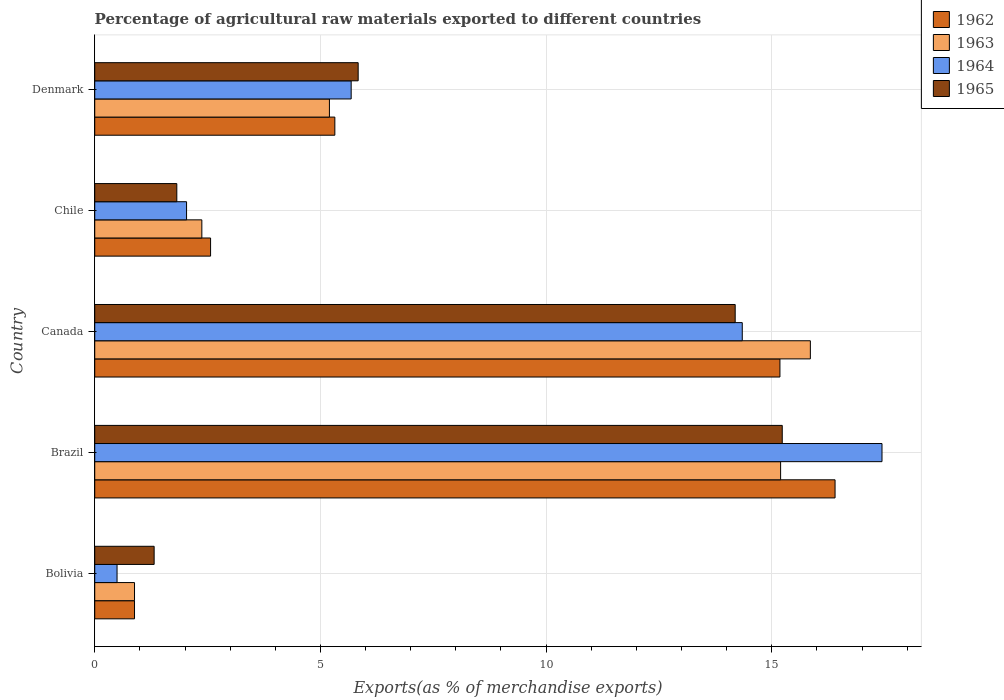How many different coloured bars are there?
Your answer should be very brief. 4. Are the number of bars per tick equal to the number of legend labels?
Ensure brevity in your answer.  Yes. How many bars are there on the 5th tick from the bottom?
Offer a very short reply. 4. In how many cases, is the number of bars for a given country not equal to the number of legend labels?
Your response must be concise. 0. What is the percentage of exports to different countries in 1963 in Brazil?
Make the answer very short. 15.2. Across all countries, what is the maximum percentage of exports to different countries in 1962?
Give a very brief answer. 16.4. Across all countries, what is the minimum percentage of exports to different countries in 1962?
Your answer should be compact. 0.88. What is the total percentage of exports to different countries in 1965 in the graph?
Provide a succinct answer. 38.39. What is the difference between the percentage of exports to different countries in 1964 in Bolivia and that in Chile?
Keep it short and to the point. -1.54. What is the difference between the percentage of exports to different countries in 1962 in Brazil and the percentage of exports to different countries in 1964 in Canada?
Your response must be concise. 2.06. What is the average percentage of exports to different countries in 1962 per country?
Offer a very short reply. 8.07. What is the difference between the percentage of exports to different countries in 1962 and percentage of exports to different countries in 1965 in Bolivia?
Ensure brevity in your answer.  -0.43. What is the ratio of the percentage of exports to different countries in 1964 in Bolivia to that in Chile?
Your answer should be very brief. 0.24. What is the difference between the highest and the second highest percentage of exports to different countries in 1963?
Keep it short and to the point. 0.66. What is the difference between the highest and the lowest percentage of exports to different countries in 1965?
Your answer should be very brief. 13.92. Is the sum of the percentage of exports to different countries in 1964 in Bolivia and Denmark greater than the maximum percentage of exports to different countries in 1962 across all countries?
Your answer should be compact. No. Is it the case that in every country, the sum of the percentage of exports to different countries in 1964 and percentage of exports to different countries in 1963 is greater than the sum of percentage of exports to different countries in 1962 and percentage of exports to different countries in 1965?
Give a very brief answer. No. What does the 1st bar from the top in Brazil represents?
Your answer should be compact. 1965. What does the 2nd bar from the bottom in Brazil represents?
Your answer should be compact. 1963. How many bars are there?
Make the answer very short. 20. Are all the bars in the graph horizontal?
Provide a short and direct response. Yes. What is the difference between two consecutive major ticks on the X-axis?
Provide a succinct answer. 5. Are the values on the major ticks of X-axis written in scientific E-notation?
Your answer should be very brief. No. Does the graph contain grids?
Offer a terse response. Yes. Where does the legend appear in the graph?
Provide a succinct answer. Top right. How many legend labels are there?
Ensure brevity in your answer.  4. How are the legend labels stacked?
Ensure brevity in your answer.  Vertical. What is the title of the graph?
Make the answer very short. Percentage of agricultural raw materials exported to different countries. What is the label or title of the X-axis?
Keep it short and to the point. Exports(as % of merchandise exports). What is the label or title of the Y-axis?
Your response must be concise. Country. What is the Exports(as % of merchandise exports) of 1962 in Bolivia?
Give a very brief answer. 0.88. What is the Exports(as % of merchandise exports) of 1963 in Bolivia?
Offer a very short reply. 0.88. What is the Exports(as % of merchandise exports) of 1964 in Bolivia?
Provide a succinct answer. 0.49. What is the Exports(as % of merchandise exports) of 1965 in Bolivia?
Your answer should be very brief. 1.32. What is the Exports(as % of merchandise exports) of 1962 in Brazil?
Your answer should be very brief. 16.4. What is the Exports(as % of merchandise exports) of 1963 in Brazil?
Keep it short and to the point. 15.2. What is the Exports(as % of merchandise exports) in 1964 in Brazil?
Your answer should be very brief. 17.44. What is the Exports(as % of merchandise exports) in 1965 in Brazil?
Your answer should be compact. 15.23. What is the Exports(as % of merchandise exports) of 1962 in Canada?
Provide a succinct answer. 15.18. What is the Exports(as % of merchandise exports) of 1963 in Canada?
Offer a very short reply. 15.85. What is the Exports(as % of merchandise exports) in 1964 in Canada?
Provide a short and direct response. 14.35. What is the Exports(as % of merchandise exports) of 1965 in Canada?
Give a very brief answer. 14.19. What is the Exports(as % of merchandise exports) in 1962 in Chile?
Provide a succinct answer. 2.57. What is the Exports(as % of merchandise exports) in 1963 in Chile?
Your answer should be compact. 2.37. What is the Exports(as % of merchandise exports) of 1964 in Chile?
Your answer should be very brief. 2.03. What is the Exports(as % of merchandise exports) in 1965 in Chile?
Provide a succinct answer. 1.82. What is the Exports(as % of merchandise exports) of 1962 in Denmark?
Keep it short and to the point. 5.32. What is the Exports(as % of merchandise exports) in 1963 in Denmark?
Ensure brevity in your answer.  5.2. What is the Exports(as % of merchandise exports) of 1964 in Denmark?
Your response must be concise. 5.68. What is the Exports(as % of merchandise exports) in 1965 in Denmark?
Make the answer very short. 5.84. Across all countries, what is the maximum Exports(as % of merchandise exports) of 1962?
Give a very brief answer. 16.4. Across all countries, what is the maximum Exports(as % of merchandise exports) of 1963?
Your response must be concise. 15.85. Across all countries, what is the maximum Exports(as % of merchandise exports) in 1964?
Offer a very short reply. 17.44. Across all countries, what is the maximum Exports(as % of merchandise exports) in 1965?
Your answer should be very brief. 15.23. Across all countries, what is the minimum Exports(as % of merchandise exports) of 1962?
Offer a very short reply. 0.88. Across all countries, what is the minimum Exports(as % of merchandise exports) in 1963?
Your response must be concise. 0.88. Across all countries, what is the minimum Exports(as % of merchandise exports) of 1964?
Give a very brief answer. 0.49. Across all countries, what is the minimum Exports(as % of merchandise exports) in 1965?
Make the answer very short. 1.32. What is the total Exports(as % of merchandise exports) in 1962 in the graph?
Your response must be concise. 40.35. What is the total Exports(as % of merchandise exports) in 1963 in the graph?
Offer a very short reply. 39.5. What is the total Exports(as % of merchandise exports) of 1964 in the graph?
Provide a succinct answer. 40. What is the total Exports(as % of merchandise exports) of 1965 in the graph?
Give a very brief answer. 38.39. What is the difference between the Exports(as % of merchandise exports) of 1962 in Bolivia and that in Brazil?
Ensure brevity in your answer.  -15.52. What is the difference between the Exports(as % of merchandise exports) in 1963 in Bolivia and that in Brazil?
Offer a very short reply. -14.31. What is the difference between the Exports(as % of merchandise exports) in 1964 in Bolivia and that in Brazil?
Your answer should be compact. -16.95. What is the difference between the Exports(as % of merchandise exports) of 1965 in Bolivia and that in Brazil?
Provide a short and direct response. -13.92. What is the difference between the Exports(as % of merchandise exports) of 1962 in Bolivia and that in Canada?
Your answer should be very brief. -14.3. What is the difference between the Exports(as % of merchandise exports) in 1963 in Bolivia and that in Canada?
Make the answer very short. -14.97. What is the difference between the Exports(as % of merchandise exports) in 1964 in Bolivia and that in Canada?
Provide a short and direct response. -13.85. What is the difference between the Exports(as % of merchandise exports) in 1965 in Bolivia and that in Canada?
Ensure brevity in your answer.  -12.87. What is the difference between the Exports(as % of merchandise exports) in 1962 in Bolivia and that in Chile?
Offer a terse response. -1.69. What is the difference between the Exports(as % of merchandise exports) in 1963 in Bolivia and that in Chile?
Your answer should be compact. -1.49. What is the difference between the Exports(as % of merchandise exports) of 1964 in Bolivia and that in Chile?
Keep it short and to the point. -1.54. What is the difference between the Exports(as % of merchandise exports) of 1965 in Bolivia and that in Chile?
Provide a succinct answer. -0.5. What is the difference between the Exports(as % of merchandise exports) of 1962 in Bolivia and that in Denmark?
Make the answer very short. -4.44. What is the difference between the Exports(as % of merchandise exports) in 1963 in Bolivia and that in Denmark?
Your answer should be compact. -4.32. What is the difference between the Exports(as % of merchandise exports) in 1964 in Bolivia and that in Denmark?
Make the answer very short. -5.19. What is the difference between the Exports(as % of merchandise exports) in 1965 in Bolivia and that in Denmark?
Provide a succinct answer. -4.52. What is the difference between the Exports(as % of merchandise exports) in 1962 in Brazil and that in Canada?
Make the answer very short. 1.22. What is the difference between the Exports(as % of merchandise exports) of 1963 in Brazil and that in Canada?
Offer a terse response. -0.66. What is the difference between the Exports(as % of merchandise exports) in 1964 in Brazil and that in Canada?
Your response must be concise. 3.1. What is the difference between the Exports(as % of merchandise exports) in 1965 in Brazil and that in Canada?
Offer a terse response. 1.04. What is the difference between the Exports(as % of merchandise exports) in 1962 in Brazil and that in Chile?
Your answer should be compact. 13.84. What is the difference between the Exports(as % of merchandise exports) of 1963 in Brazil and that in Chile?
Provide a short and direct response. 12.82. What is the difference between the Exports(as % of merchandise exports) in 1964 in Brazil and that in Chile?
Keep it short and to the point. 15.41. What is the difference between the Exports(as % of merchandise exports) in 1965 in Brazil and that in Chile?
Provide a succinct answer. 13.41. What is the difference between the Exports(as % of merchandise exports) in 1962 in Brazil and that in Denmark?
Provide a short and direct response. 11.08. What is the difference between the Exports(as % of merchandise exports) of 1963 in Brazil and that in Denmark?
Ensure brevity in your answer.  10. What is the difference between the Exports(as % of merchandise exports) of 1964 in Brazil and that in Denmark?
Your answer should be compact. 11.76. What is the difference between the Exports(as % of merchandise exports) of 1965 in Brazil and that in Denmark?
Provide a succinct answer. 9.4. What is the difference between the Exports(as % of merchandise exports) in 1962 in Canada and that in Chile?
Offer a terse response. 12.61. What is the difference between the Exports(as % of merchandise exports) of 1963 in Canada and that in Chile?
Offer a very short reply. 13.48. What is the difference between the Exports(as % of merchandise exports) in 1964 in Canada and that in Chile?
Ensure brevity in your answer.  12.31. What is the difference between the Exports(as % of merchandise exports) in 1965 in Canada and that in Chile?
Make the answer very short. 12.37. What is the difference between the Exports(as % of merchandise exports) in 1962 in Canada and that in Denmark?
Your answer should be compact. 9.86. What is the difference between the Exports(as % of merchandise exports) in 1963 in Canada and that in Denmark?
Keep it short and to the point. 10.65. What is the difference between the Exports(as % of merchandise exports) in 1964 in Canada and that in Denmark?
Your answer should be very brief. 8.66. What is the difference between the Exports(as % of merchandise exports) in 1965 in Canada and that in Denmark?
Give a very brief answer. 8.35. What is the difference between the Exports(as % of merchandise exports) of 1962 in Chile and that in Denmark?
Your answer should be very brief. -2.75. What is the difference between the Exports(as % of merchandise exports) in 1963 in Chile and that in Denmark?
Make the answer very short. -2.83. What is the difference between the Exports(as % of merchandise exports) in 1964 in Chile and that in Denmark?
Give a very brief answer. -3.65. What is the difference between the Exports(as % of merchandise exports) of 1965 in Chile and that in Denmark?
Keep it short and to the point. -4.02. What is the difference between the Exports(as % of merchandise exports) of 1962 in Bolivia and the Exports(as % of merchandise exports) of 1963 in Brazil?
Provide a short and direct response. -14.31. What is the difference between the Exports(as % of merchandise exports) of 1962 in Bolivia and the Exports(as % of merchandise exports) of 1964 in Brazil?
Offer a terse response. -16.56. What is the difference between the Exports(as % of merchandise exports) of 1962 in Bolivia and the Exports(as % of merchandise exports) of 1965 in Brazil?
Provide a short and direct response. -14.35. What is the difference between the Exports(as % of merchandise exports) of 1963 in Bolivia and the Exports(as % of merchandise exports) of 1964 in Brazil?
Provide a short and direct response. -16.56. What is the difference between the Exports(as % of merchandise exports) of 1963 in Bolivia and the Exports(as % of merchandise exports) of 1965 in Brazil?
Ensure brevity in your answer.  -14.35. What is the difference between the Exports(as % of merchandise exports) in 1964 in Bolivia and the Exports(as % of merchandise exports) in 1965 in Brazil?
Your answer should be very brief. -14.74. What is the difference between the Exports(as % of merchandise exports) in 1962 in Bolivia and the Exports(as % of merchandise exports) in 1963 in Canada?
Provide a short and direct response. -14.97. What is the difference between the Exports(as % of merchandise exports) in 1962 in Bolivia and the Exports(as % of merchandise exports) in 1964 in Canada?
Provide a succinct answer. -13.46. What is the difference between the Exports(as % of merchandise exports) of 1962 in Bolivia and the Exports(as % of merchandise exports) of 1965 in Canada?
Provide a short and direct response. -13.31. What is the difference between the Exports(as % of merchandise exports) in 1963 in Bolivia and the Exports(as % of merchandise exports) in 1964 in Canada?
Offer a very short reply. -13.46. What is the difference between the Exports(as % of merchandise exports) in 1963 in Bolivia and the Exports(as % of merchandise exports) in 1965 in Canada?
Your answer should be compact. -13.31. What is the difference between the Exports(as % of merchandise exports) in 1964 in Bolivia and the Exports(as % of merchandise exports) in 1965 in Canada?
Your answer should be compact. -13.7. What is the difference between the Exports(as % of merchandise exports) of 1962 in Bolivia and the Exports(as % of merchandise exports) of 1963 in Chile?
Your answer should be compact. -1.49. What is the difference between the Exports(as % of merchandise exports) of 1962 in Bolivia and the Exports(as % of merchandise exports) of 1964 in Chile?
Give a very brief answer. -1.15. What is the difference between the Exports(as % of merchandise exports) of 1962 in Bolivia and the Exports(as % of merchandise exports) of 1965 in Chile?
Offer a terse response. -0.94. What is the difference between the Exports(as % of merchandise exports) of 1963 in Bolivia and the Exports(as % of merchandise exports) of 1964 in Chile?
Give a very brief answer. -1.15. What is the difference between the Exports(as % of merchandise exports) of 1963 in Bolivia and the Exports(as % of merchandise exports) of 1965 in Chile?
Provide a short and direct response. -0.94. What is the difference between the Exports(as % of merchandise exports) in 1964 in Bolivia and the Exports(as % of merchandise exports) in 1965 in Chile?
Offer a terse response. -1.32. What is the difference between the Exports(as % of merchandise exports) in 1962 in Bolivia and the Exports(as % of merchandise exports) in 1963 in Denmark?
Your answer should be very brief. -4.32. What is the difference between the Exports(as % of merchandise exports) in 1962 in Bolivia and the Exports(as % of merchandise exports) in 1964 in Denmark?
Your response must be concise. -4.8. What is the difference between the Exports(as % of merchandise exports) in 1962 in Bolivia and the Exports(as % of merchandise exports) in 1965 in Denmark?
Offer a very short reply. -4.95. What is the difference between the Exports(as % of merchandise exports) in 1963 in Bolivia and the Exports(as % of merchandise exports) in 1964 in Denmark?
Make the answer very short. -4.8. What is the difference between the Exports(as % of merchandise exports) in 1963 in Bolivia and the Exports(as % of merchandise exports) in 1965 in Denmark?
Your answer should be very brief. -4.95. What is the difference between the Exports(as % of merchandise exports) in 1964 in Bolivia and the Exports(as % of merchandise exports) in 1965 in Denmark?
Offer a terse response. -5.34. What is the difference between the Exports(as % of merchandise exports) of 1962 in Brazil and the Exports(as % of merchandise exports) of 1963 in Canada?
Make the answer very short. 0.55. What is the difference between the Exports(as % of merchandise exports) in 1962 in Brazil and the Exports(as % of merchandise exports) in 1964 in Canada?
Your answer should be compact. 2.06. What is the difference between the Exports(as % of merchandise exports) in 1962 in Brazil and the Exports(as % of merchandise exports) in 1965 in Canada?
Give a very brief answer. 2.21. What is the difference between the Exports(as % of merchandise exports) of 1963 in Brazil and the Exports(as % of merchandise exports) of 1964 in Canada?
Provide a short and direct response. 0.85. What is the difference between the Exports(as % of merchandise exports) in 1963 in Brazil and the Exports(as % of merchandise exports) in 1965 in Canada?
Your answer should be very brief. 1.01. What is the difference between the Exports(as % of merchandise exports) in 1964 in Brazil and the Exports(as % of merchandise exports) in 1965 in Canada?
Make the answer very short. 3.25. What is the difference between the Exports(as % of merchandise exports) in 1962 in Brazil and the Exports(as % of merchandise exports) in 1963 in Chile?
Make the answer very short. 14.03. What is the difference between the Exports(as % of merchandise exports) of 1962 in Brazil and the Exports(as % of merchandise exports) of 1964 in Chile?
Make the answer very short. 14.37. What is the difference between the Exports(as % of merchandise exports) in 1962 in Brazil and the Exports(as % of merchandise exports) in 1965 in Chile?
Your response must be concise. 14.58. What is the difference between the Exports(as % of merchandise exports) in 1963 in Brazil and the Exports(as % of merchandise exports) in 1964 in Chile?
Provide a succinct answer. 13.16. What is the difference between the Exports(as % of merchandise exports) of 1963 in Brazil and the Exports(as % of merchandise exports) of 1965 in Chile?
Provide a short and direct response. 13.38. What is the difference between the Exports(as % of merchandise exports) in 1964 in Brazil and the Exports(as % of merchandise exports) in 1965 in Chile?
Offer a very short reply. 15.62. What is the difference between the Exports(as % of merchandise exports) in 1962 in Brazil and the Exports(as % of merchandise exports) in 1963 in Denmark?
Offer a terse response. 11.2. What is the difference between the Exports(as % of merchandise exports) in 1962 in Brazil and the Exports(as % of merchandise exports) in 1964 in Denmark?
Your answer should be compact. 10.72. What is the difference between the Exports(as % of merchandise exports) of 1962 in Brazil and the Exports(as % of merchandise exports) of 1965 in Denmark?
Offer a very short reply. 10.57. What is the difference between the Exports(as % of merchandise exports) of 1963 in Brazil and the Exports(as % of merchandise exports) of 1964 in Denmark?
Your answer should be compact. 9.51. What is the difference between the Exports(as % of merchandise exports) of 1963 in Brazil and the Exports(as % of merchandise exports) of 1965 in Denmark?
Keep it short and to the point. 9.36. What is the difference between the Exports(as % of merchandise exports) in 1964 in Brazil and the Exports(as % of merchandise exports) in 1965 in Denmark?
Give a very brief answer. 11.61. What is the difference between the Exports(as % of merchandise exports) of 1962 in Canada and the Exports(as % of merchandise exports) of 1963 in Chile?
Make the answer very short. 12.81. What is the difference between the Exports(as % of merchandise exports) of 1962 in Canada and the Exports(as % of merchandise exports) of 1964 in Chile?
Provide a succinct answer. 13.15. What is the difference between the Exports(as % of merchandise exports) in 1962 in Canada and the Exports(as % of merchandise exports) in 1965 in Chile?
Make the answer very short. 13.36. What is the difference between the Exports(as % of merchandise exports) in 1963 in Canada and the Exports(as % of merchandise exports) in 1964 in Chile?
Keep it short and to the point. 13.82. What is the difference between the Exports(as % of merchandise exports) in 1963 in Canada and the Exports(as % of merchandise exports) in 1965 in Chile?
Provide a short and direct response. 14.04. What is the difference between the Exports(as % of merchandise exports) of 1964 in Canada and the Exports(as % of merchandise exports) of 1965 in Chile?
Your answer should be compact. 12.53. What is the difference between the Exports(as % of merchandise exports) in 1962 in Canada and the Exports(as % of merchandise exports) in 1963 in Denmark?
Ensure brevity in your answer.  9.98. What is the difference between the Exports(as % of merchandise exports) of 1962 in Canada and the Exports(as % of merchandise exports) of 1964 in Denmark?
Provide a short and direct response. 9.5. What is the difference between the Exports(as % of merchandise exports) in 1962 in Canada and the Exports(as % of merchandise exports) in 1965 in Denmark?
Provide a short and direct response. 9.34. What is the difference between the Exports(as % of merchandise exports) in 1963 in Canada and the Exports(as % of merchandise exports) in 1964 in Denmark?
Keep it short and to the point. 10.17. What is the difference between the Exports(as % of merchandise exports) of 1963 in Canada and the Exports(as % of merchandise exports) of 1965 in Denmark?
Provide a succinct answer. 10.02. What is the difference between the Exports(as % of merchandise exports) of 1964 in Canada and the Exports(as % of merchandise exports) of 1965 in Denmark?
Give a very brief answer. 8.51. What is the difference between the Exports(as % of merchandise exports) of 1962 in Chile and the Exports(as % of merchandise exports) of 1963 in Denmark?
Offer a very short reply. -2.63. What is the difference between the Exports(as % of merchandise exports) in 1962 in Chile and the Exports(as % of merchandise exports) in 1964 in Denmark?
Give a very brief answer. -3.11. What is the difference between the Exports(as % of merchandise exports) in 1962 in Chile and the Exports(as % of merchandise exports) in 1965 in Denmark?
Provide a short and direct response. -3.27. What is the difference between the Exports(as % of merchandise exports) in 1963 in Chile and the Exports(as % of merchandise exports) in 1964 in Denmark?
Give a very brief answer. -3.31. What is the difference between the Exports(as % of merchandise exports) in 1963 in Chile and the Exports(as % of merchandise exports) in 1965 in Denmark?
Provide a short and direct response. -3.46. What is the difference between the Exports(as % of merchandise exports) of 1964 in Chile and the Exports(as % of merchandise exports) of 1965 in Denmark?
Offer a terse response. -3.8. What is the average Exports(as % of merchandise exports) in 1962 per country?
Your answer should be compact. 8.07. What is the average Exports(as % of merchandise exports) of 1963 per country?
Provide a short and direct response. 7.9. What is the average Exports(as % of merchandise exports) in 1964 per country?
Provide a succinct answer. 8. What is the average Exports(as % of merchandise exports) of 1965 per country?
Your answer should be compact. 7.68. What is the difference between the Exports(as % of merchandise exports) of 1962 and Exports(as % of merchandise exports) of 1964 in Bolivia?
Ensure brevity in your answer.  0.39. What is the difference between the Exports(as % of merchandise exports) of 1962 and Exports(as % of merchandise exports) of 1965 in Bolivia?
Offer a terse response. -0.43. What is the difference between the Exports(as % of merchandise exports) of 1963 and Exports(as % of merchandise exports) of 1964 in Bolivia?
Provide a succinct answer. 0.39. What is the difference between the Exports(as % of merchandise exports) in 1963 and Exports(as % of merchandise exports) in 1965 in Bolivia?
Your answer should be compact. -0.43. What is the difference between the Exports(as % of merchandise exports) in 1964 and Exports(as % of merchandise exports) in 1965 in Bolivia?
Provide a short and direct response. -0.82. What is the difference between the Exports(as % of merchandise exports) in 1962 and Exports(as % of merchandise exports) in 1963 in Brazil?
Offer a terse response. 1.21. What is the difference between the Exports(as % of merchandise exports) in 1962 and Exports(as % of merchandise exports) in 1964 in Brazil?
Your answer should be very brief. -1.04. What is the difference between the Exports(as % of merchandise exports) of 1962 and Exports(as % of merchandise exports) of 1965 in Brazil?
Offer a very short reply. 1.17. What is the difference between the Exports(as % of merchandise exports) of 1963 and Exports(as % of merchandise exports) of 1964 in Brazil?
Your response must be concise. -2.25. What is the difference between the Exports(as % of merchandise exports) of 1963 and Exports(as % of merchandise exports) of 1965 in Brazil?
Ensure brevity in your answer.  -0.04. What is the difference between the Exports(as % of merchandise exports) of 1964 and Exports(as % of merchandise exports) of 1965 in Brazil?
Provide a short and direct response. 2.21. What is the difference between the Exports(as % of merchandise exports) in 1962 and Exports(as % of merchandise exports) in 1963 in Canada?
Give a very brief answer. -0.67. What is the difference between the Exports(as % of merchandise exports) in 1962 and Exports(as % of merchandise exports) in 1964 in Canada?
Offer a very short reply. 0.83. What is the difference between the Exports(as % of merchandise exports) in 1963 and Exports(as % of merchandise exports) in 1964 in Canada?
Make the answer very short. 1.51. What is the difference between the Exports(as % of merchandise exports) in 1963 and Exports(as % of merchandise exports) in 1965 in Canada?
Provide a succinct answer. 1.67. What is the difference between the Exports(as % of merchandise exports) of 1964 and Exports(as % of merchandise exports) of 1965 in Canada?
Offer a terse response. 0.16. What is the difference between the Exports(as % of merchandise exports) in 1962 and Exports(as % of merchandise exports) in 1963 in Chile?
Give a very brief answer. 0.19. What is the difference between the Exports(as % of merchandise exports) of 1962 and Exports(as % of merchandise exports) of 1964 in Chile?
Make the answer very short. 0.53. What is the difference between the Exports(as % of merchandise exports) in 1962 and Exports(as % of merchandise exports) in 1965 in Chile?
Your response must be concise. 0.75. What is the difference between the Exports(as % of merchandise exports) of 1963 and Exports(as % of merchandise exports) of 1964 in Chile?
Your answer should be compact. 0.34. What is the difference between the Exports(as % of merchandise exports) in 1963 and Exports(as % of merchandise exports) in 1965 in Chile?
Make the answer very short. 0.55. What is the difference between the Exports(as % of merchandise exports) in 1964 and Exports(as % of merchandise exports) in 1965 in Chile?
Offer a terse response. 0.22. What is the difference between the Exports(as % of merchandise exports) of 1962 and Exports(as % of merchandise exports) of 1963 in Denmark?
Your response must be concise. 0.12. What is the difference between the Exports(as % of merchandise exports) in 1962 and Exports(as % of merchandise exports) in 1964 in Denmark?
Give a very brief answer. -0.36. What is the difference between the Exports(as % of merchandise exports) of 1962 and Exports(as % of merchandise exports) of 1965 in Denmark?
Provide a short and direct response. -0.52. What is the difference between the Exports(as % of merchandise exports) in 1963 and Exports(as % of merchandise exports) in 1964 in Denmark?
Your answer should be very brief. -0.48. What is the difference between the Exports(as % of merchandise exports) of 1963 and Exports(as % of merchandise exports) of 1965 in Denmark?
Give a very brief answer. -0.64. What is the difference between the Exports(as % of merchandise exports) of 1964 and Exports(as % of merchandise exports) of 1965 in Denmark?
Your answer should be very brief. -0.15. What is the ratio of the Exports(as % of merchandise exports) in 1962 in Bolivia to that in Brazil?
Give a very brief answer. 0.05. What is the ratio of the Exports(as % of merchandise exports) in 1963 in Bolivia to that in Brazil?
Give a very brief answer. 0.06. What is the ratio of the Exports(as % of merchandise exports) in 1964 in Bolivia to that in Brazil?
Keep it short and to the point. 0.03. What is the ratio of the Exports(as % of merchandise exports) of 1965 in Bolivia to that in Brazil?
Provide a short and direct response. 0.09. What is the ratio of the Exports(as % of merchandise exports) in 1962 in Bolivia to that in Canada?
Make the answer very short. 0.06. What is the ratio of the Exports(as % of merchandise exports) in 1963 in Bolivia to that in Canada?
Provide a short and direct response. 0.06. What is the ratio of the Exports(as % of merchandise exports) of 1964 in Bolivia to that in Canada?
Your answer should be very brief. 0.03. What is the ratio of the Exports(as % of merchandise exports) of 1965 in Bolivia to that in Canada?
Your response must be concise. 0.09. What is the ratio of the Exports(as % of merchandise exports) in 1962 in Bolivia to that in Chile?
Provide a succinct answer. 0.34. What is the ratio of the Exports(as % of merchandise exports) in 1963 in Bolivia to that in Chile?
Provide a succinct answer. 0.37. What is the ratio of the Exports(as % of merchandise exports) in 1964 in Bolivia to that in Chile?
Your answer should be very brief. 0.24. What is the ratio of the Exports(as % of merchandise exports) in 1965 in Bolivia to that in Chile?
Your answer should be very brief. 0.72. What is the ratio of the Exports(as % of merchandise exports) in 1962 in Bolivia to that in Denmark?
Provide a succinct answer. 0.17. What is the ratio of the Exports(as % of merchandise exports) of 1963 in Bolivia to that in Denmark?
Provide a succinct answer. 0.17. What is the ratio of the Exports(as % of merchandise exports) of 1964 in Bolivia to that in Denmark?
Provide a succinct answer. 0.09. What is the ratio of the Exports(as % of merchandise exports) in 1965 in Bolivia to that in Denmark?
Keep it short and to the point. 0.23. What is the ratio of the Exports(as % of merchandise exports) in 1962 in Brazil to that in Canada?
Make the answer very short. 1.08. What is the ratio of the Exports(as % of merchandise exports) in 1963 in Brazil to that in Canada?
Give a very brief answer. 0.96. What is the ratio of the Exports(as % of merchandise exports) in 1964 in Brazil to that in Canada?
Give a very brief answer. 1.22. What is the ratio of the Exports(as % of merchandise exports) of 1965 in Brazil to that in Canada?
Provide a short and direct response. 1.07. What is the ratio of the Exports(as % of merchandise exports) of 1962 in Brazil to that in Chile?
Offer a terse response. 6.39. What is the ratio of the Exports(as % of merchandise exports) of 1963 in Brazil to that in Chile?
Provide a short and direct response. 6.4. What is the ratio of the Exports(as % of merchandise exports) of 1964 in Brazil to that in Chile?
Your answer should be compact. 8.57. What is the ratio of the Exports(as % of merchandise exports) in 1965 in Brazil to that in Chile?
Ensure brevity in your answer.  8.38. What is the ratio of the Exports(as % of merchandise exports) of 1962 in Brazil to that in Denmark?
Provide a succinct answer. 3.08. What is the ratio of the Exports(as % of merchandise exports) in 1963 in Brazil to that in Denmark?
Offer a very short reply. 2.92. What is the ratio of the Exports(as % of merchandise exports) of 1964 in Brazil to that in Denmark?
Your answer should be compact. 3.07. What is the ratio of the Exports(as % of merchandise exports) in 1965 in Brazil to that in Denmark?
Provide a succinct answer. 2.61. What is the ratio of the Exports(as % of merchandise exports) in 1962 in Canada to that in Chile?
Keep it short and to the point. 5.91. What is the ratio of the Exports(as % of merchandise exports) in 1963 in Canada to that in Chile?
Provide a short and direct response. 6.68. What is the ratio of the Exports(as % of merchandise exports) of 1964 in Canada to that in Chile?
Provide a short and direct response. 7.05. What is the ratio of the Exports(as % of merchandise exports) of 1965 in Canada to that in Chile?
Offer a terse response. 7.8. What is the ratio of the Exports(as % of merchandise exports) of 1962 in Canada to that in Denmark?
Your answer should be compact. 2.85. What is the ratio of the Exports(as % of merchandise exports) of 1963 in Canada to that in Denmark?
Ensure brevity in your answer.  3.05. What is the ratio of the Exports(as % of merchandise exports) in 1964 in Canada to that in Denmark?
Offer a terse response. 2.53. What is the ratio of the Exports(as % of merchandise exports) of 1965 in Canada to that in Denmark?
Your response must be concise. 2.43. What is the ratio of the Exports(as % of merchandise exports) of 1962 in Chile to that in Denmark?
Provide a short and direct response. 0.48. What is the ratio of the Exports(as % of merchandise exports) in 1963 in Chile to that in Denmark?
Offer a terse response. 0.46. What is the ratio of the Exports(as % of merchandise exports) of 1964 in Chile to that in Denmark?
Offer a very short reply. 0.36. What is the ratio of the Exports(as % of merchandise exports) in 1965 in Chile to that in Denmark?
Offer a very short reply. 0.31. What is the difference between the highest and the second highest Exports(as % of merchandise exports) of 1962?
Provide a short and direct response. 1.22. What is the difference between the highest and the second highest Exports(as % of merchandise exports) of 1963?
Offer a terse response. 0.66. What is the difference between the highest and the second highest Exports(as % of merchandise exports) in 1964?
Your response must be concise. 3.1. What is the difference between the highest and the second highest Exports(as % of merchandise exports) in 1965?
Provide a short and direct response. 1.04. What is the difference between the highest and the lowest Exports(as % of merchandise exports) in 1962?
Provide a short and direct response. 15.52. What is the difference between the highest and the lowest Exports(as % of merchandise exports) in 1963?
Provide a succinct answer. 14.97. What is the difference between the highest and the lowest Exports(as % of merchandise exports) in 1964?
Offer a very short reply. 16.95. What is the difference between the highest and the lowest Exports(as % of merchandise exports) in 1965?
Your answer should be very brief. 13.92. 